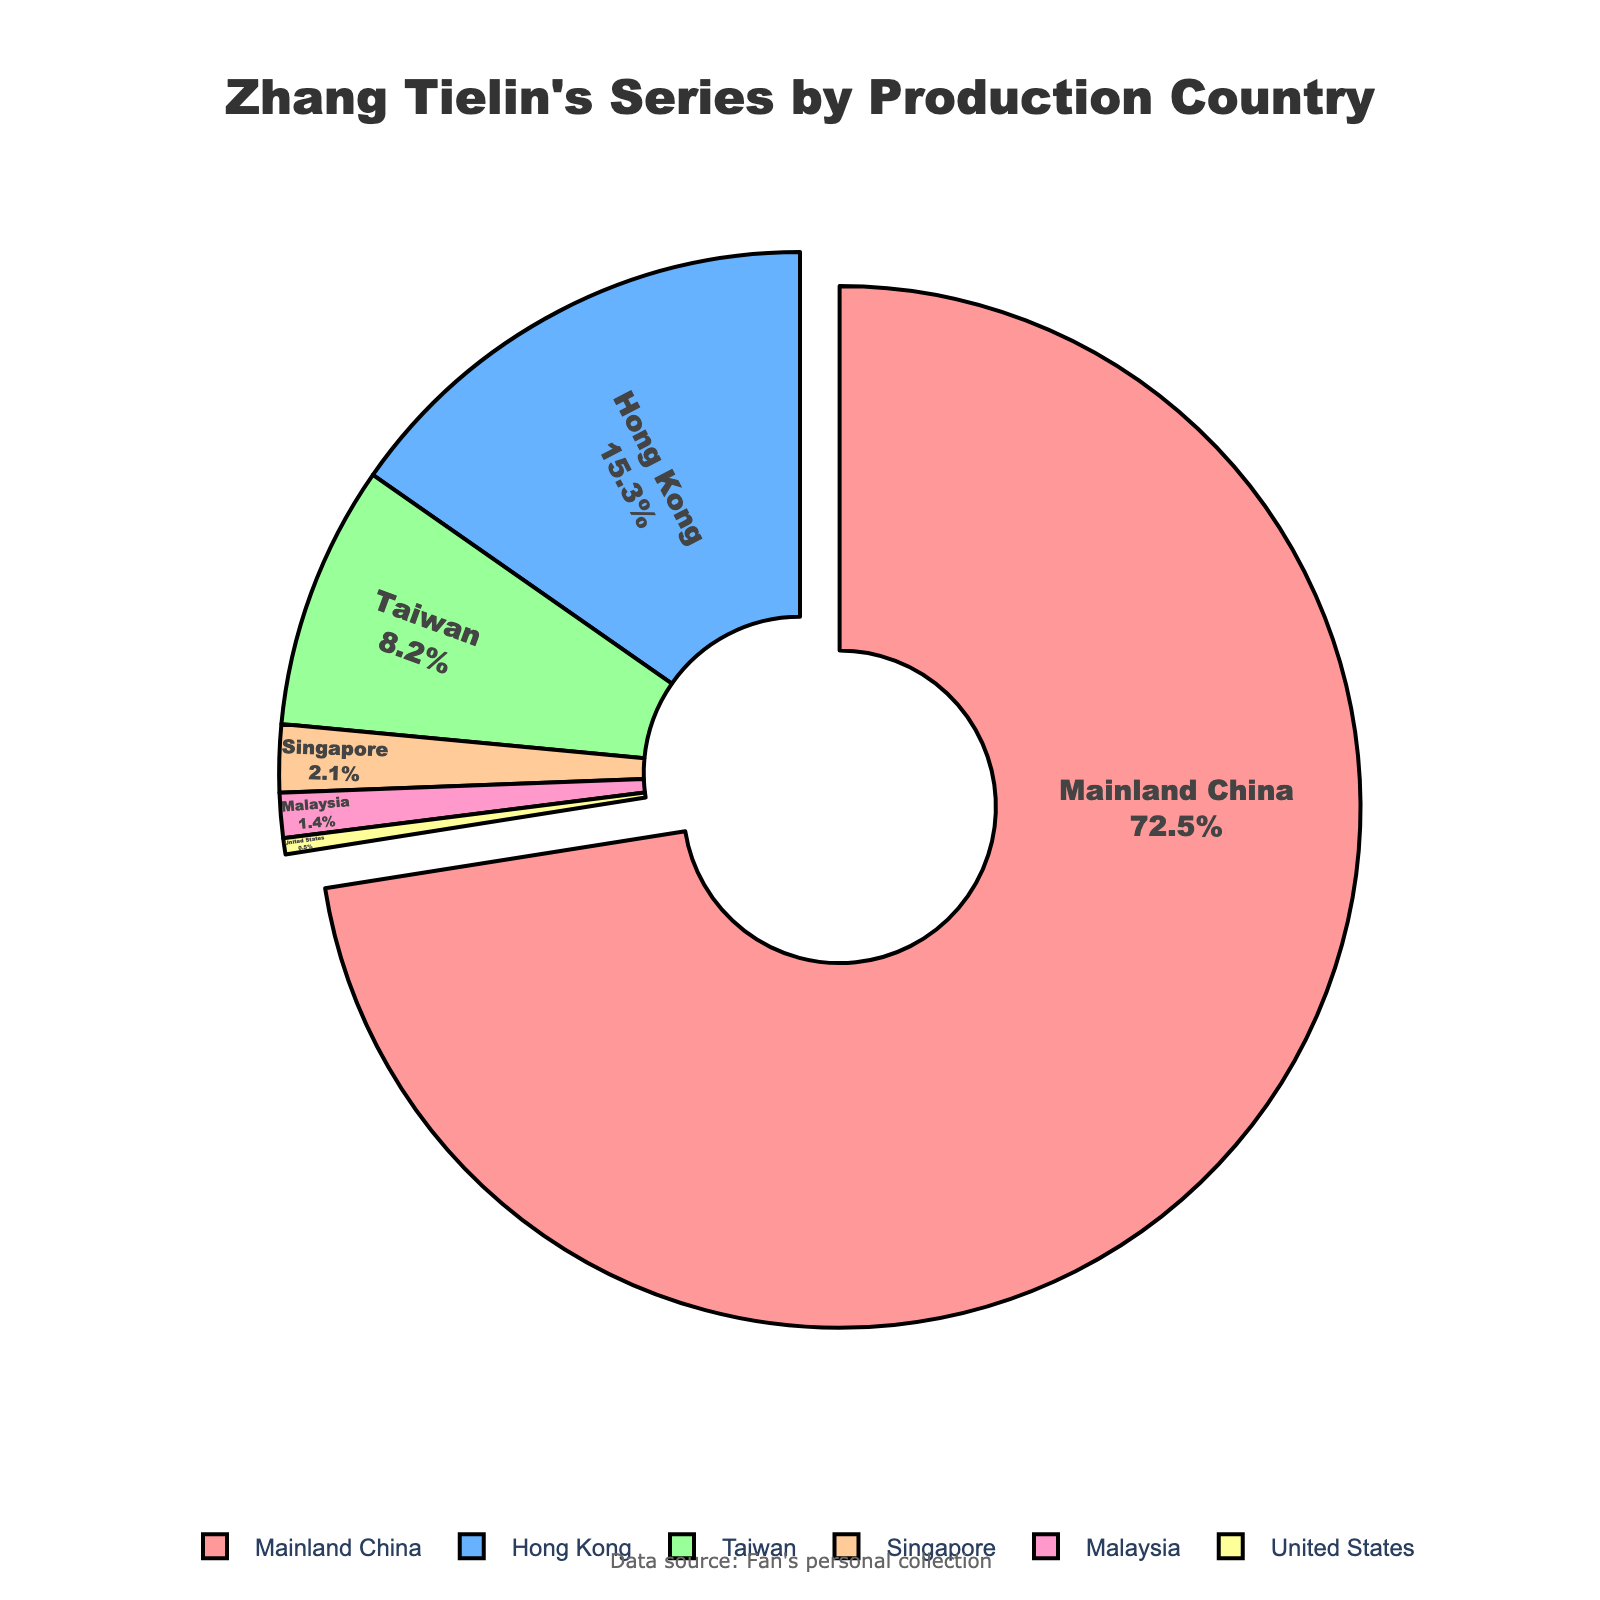Which production country has the highest percentage of Zhang Tielin's series? Mainland China has the highest percentage, indicated by a notably large section of the pie chart. By visual comparison, simple observation shows that Mainland China occupies the largest segment of the pie.
Answer: Mainland China What's the percentage difference between series produced in Mainland China and Hong Kong? The percentage for Mainland China is 72.5%, and the percentage for Hong Kong is 15.3%. Subtracting these two values gives: 72.5 - 15.3 = 57.2%.
Answer: 57.2% Are there more series produced in Taiwan or Singapore? By comparing the pie chart segments, Taiwan has a larger section than Singapore. Checking the values confirms that Taiwan has 8.2%, whereas Singapore has 2.1%, so Taiwan produced more.
Answer: Taiwan What is the combined percentage of Zhang Tielin’s series produced in Hong Kong and Taiwan? Adding the percentages for Hong Kong (15.3%) and Taiwan (8.2%) gives: 15.3 + 8.2 = 23.5%.
Answer: 23.5% Which production country occupies the smallest segment of the pie chart? The smallest segment visually on the pie chart belongs to the United States. Checking the values, the United States has the smallest percentage at 0.5%.
Answer: United States What is the difference in percentage between series produced in Singapore and Malaysia? The percentage for Singapore is 2.1%, and the percentage for Malaysia is 1.4%. Subtracting these values gives: 2.1 - 1.4 = 0.7%.
Answer: 0.7% How many countries contributed less than 5% of Zhang Tielin’s series each? From the values: Taiwan (8.2%), Singapore (2.1%), Malaysia (1.4%), United States (0.5%), three countries have less than 5% each: Singapore, Malaysia, and the United States.
Answer: 3 Compare the combined percentage of series produced in Singapore and Malaysia to that produced in Hong Kong. Adding Singapore's 2.1% and Malaysia's 1.4% gives 2.1 + 1.4 = 3.5%, which is less than Hong Kong’s 15.3%.
Answer: less What percentage of Zhang Tielin’s series was produced outside of Mainland China? Summing percentages of all countries except Mainland China (72.5%), gives: 15.3 (Hong Kong) + 8.2 (Taiwan) + 2.1 (Singapore) + 1.4 (Malaysia) + 0.5 (United States) = 27.5%.
Answer: 27.5% What color represents the segment with a 2.1% production contribution? Looking at the pie chart’s segment with 2.1%, which is Singapore, the color used is light orange.
Answer: light orange 